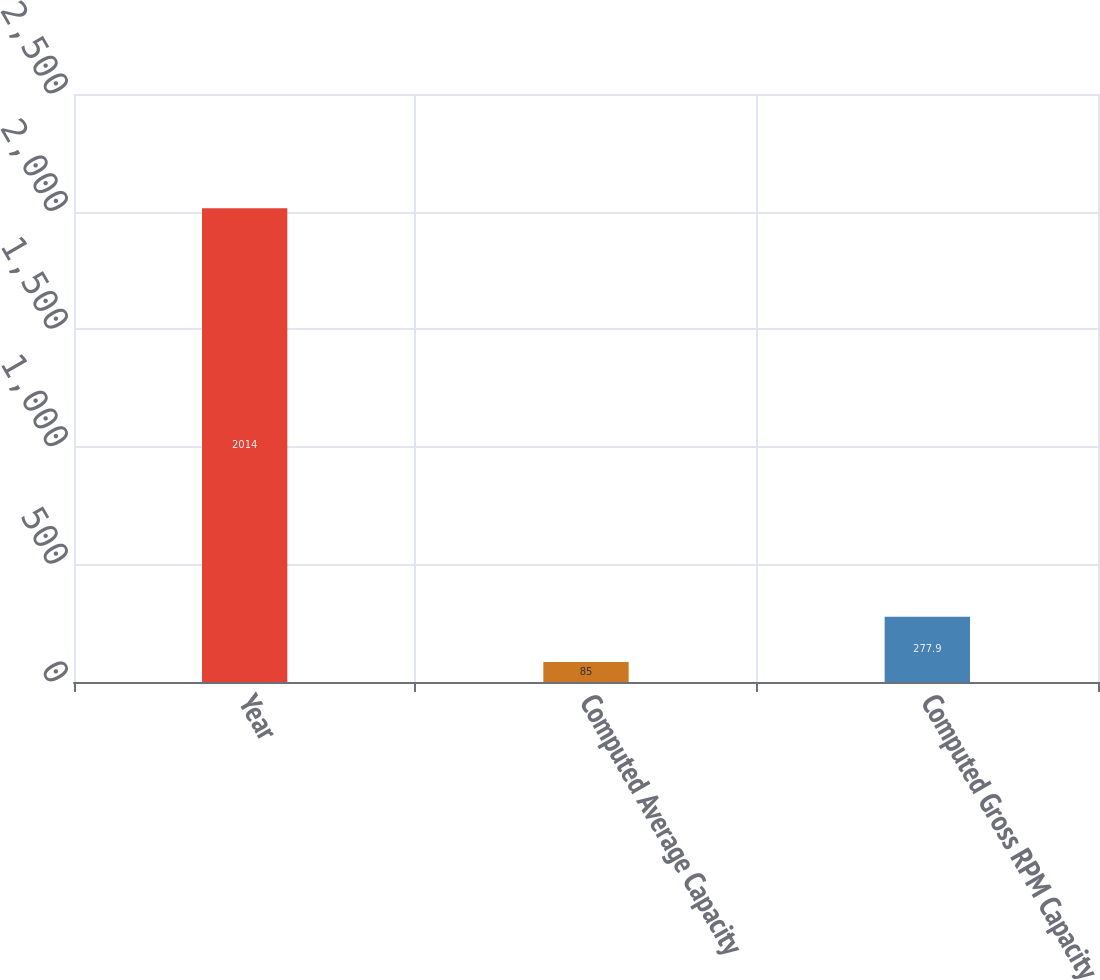<chart> <loc_0><loc_0><loc_500><loc_500><bar_chart><fcel>Year<fcel>Computed Average Capacity<fcel>Computed Gross RPM Capacity<nl><fcel>2014<fcel>85<fcel>277.9<nl></chart> 